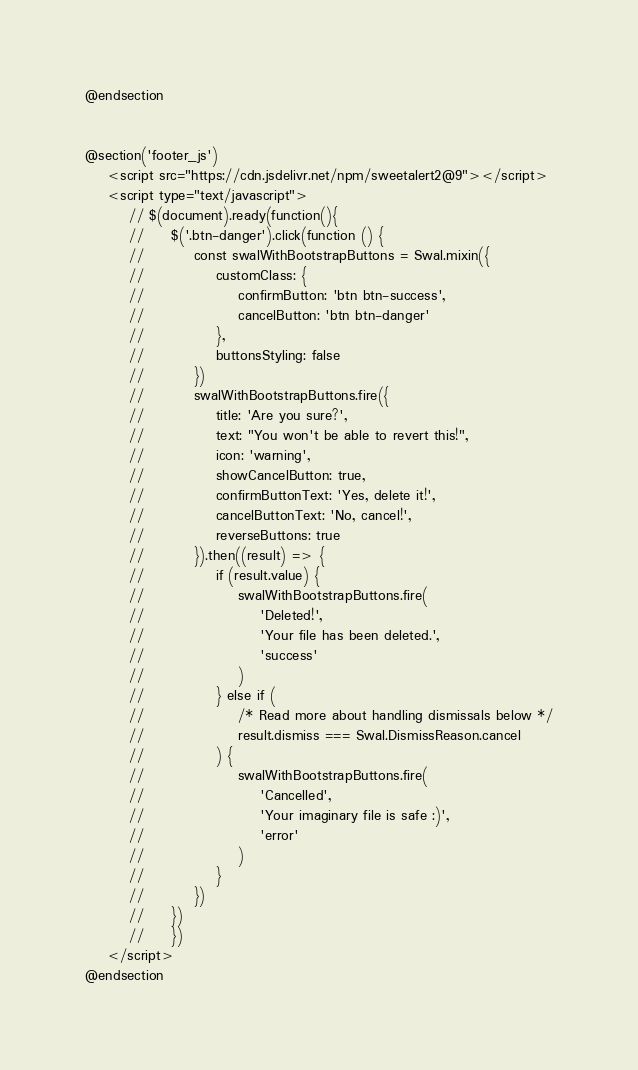<code> <loc_0><loc_0><loc_500><loc_500><_PHP_>@endsection


@section('footer_js')
    <script src="https://cdn.jsdelivr.net/npm/sweetalert2@9"></script>
    <script type="text/javascript">
        // $(document).ready(function(){
        //     $('.btn-danger').click(function () {
        //         const swalWithBootstrapButtons = Swal.mixin({
        //             customClass: {
        //                 confirmButton: 'btn btn-success',
        //                 cancelButton: 'btn btn-danger'
        //             },
        //             buttonsStyling: false
        //         })
        //         swalWithBootstrapButtons.fire({
        //             title: 'Are you sure?',
        //             text: "You won't be able to revert this!",
        //             icon: 'warning',
        //             showCancelButton: true,
        //             confirmButtonText: 'Yes, delete it!',
        //             cancelButtonText: 'No, cancel!',
        //             reverseButtons: true
        //         }).then((result) => {
        //             if (result.value) {
        //                 swalWithBootstrapButtons.fire(
        //                     'Deleted!',
        //                     'Your file has been deleted.',
        //                     'success'
        //                 )
        //             } else if (
        //                 /* Read more about handling dismissals below */
        //                 result.dismiss === Swal.DismissReason.cancel
        //             ) {
        //                 swalWithBootstrapButtons.fire(
        //                     'Cancelled',
        //                     'Your imaginary file is safe :)',
        //                     'error'
        //                 )
        //             }
        //         })
        //     })
        //     })
    </script>
@endsection
</code> 